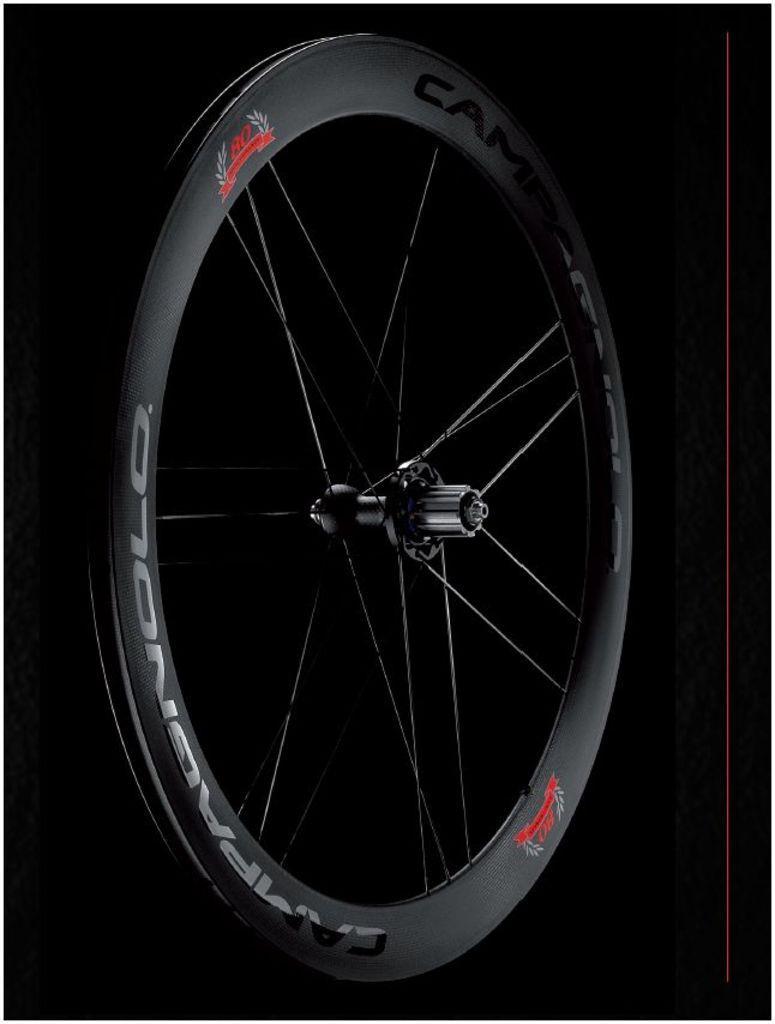Describe this image in one or two sentences. In this picture we can see a wheel here, there are some spokes here, we can see a dark background here, there is some text on the wheel. 